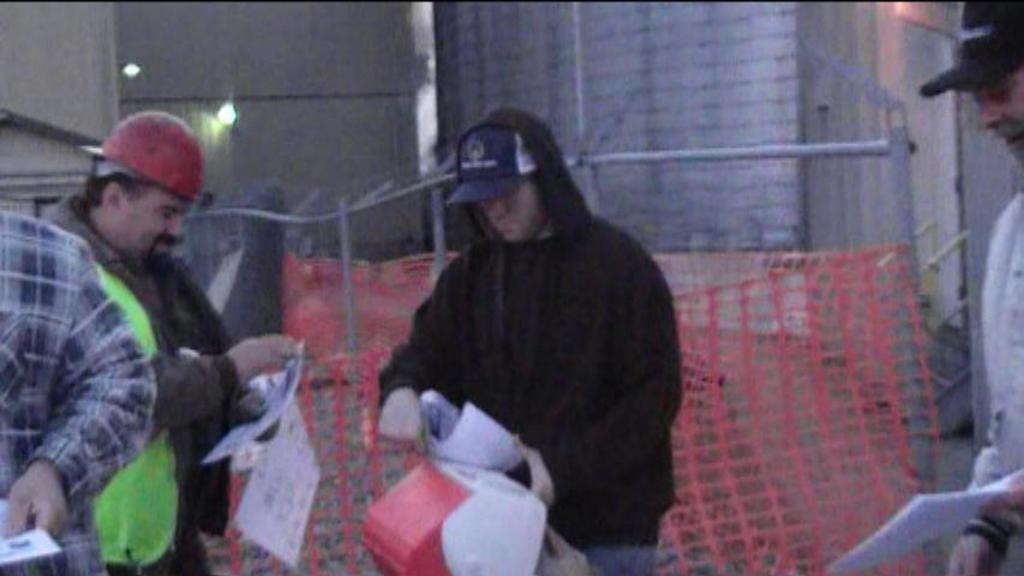What are the people in the image doing? The people in the image are standing and holding papers. What objects can be seen in the image besides the people? There is a net and rods visible in the image. What is in the background of the image? There is a wall in the background of the image. What type of writer is present in the image? There is no writer present in the image. What is the value of the step in the image? There is no step present in the image, so it is not possible to determine its value. 